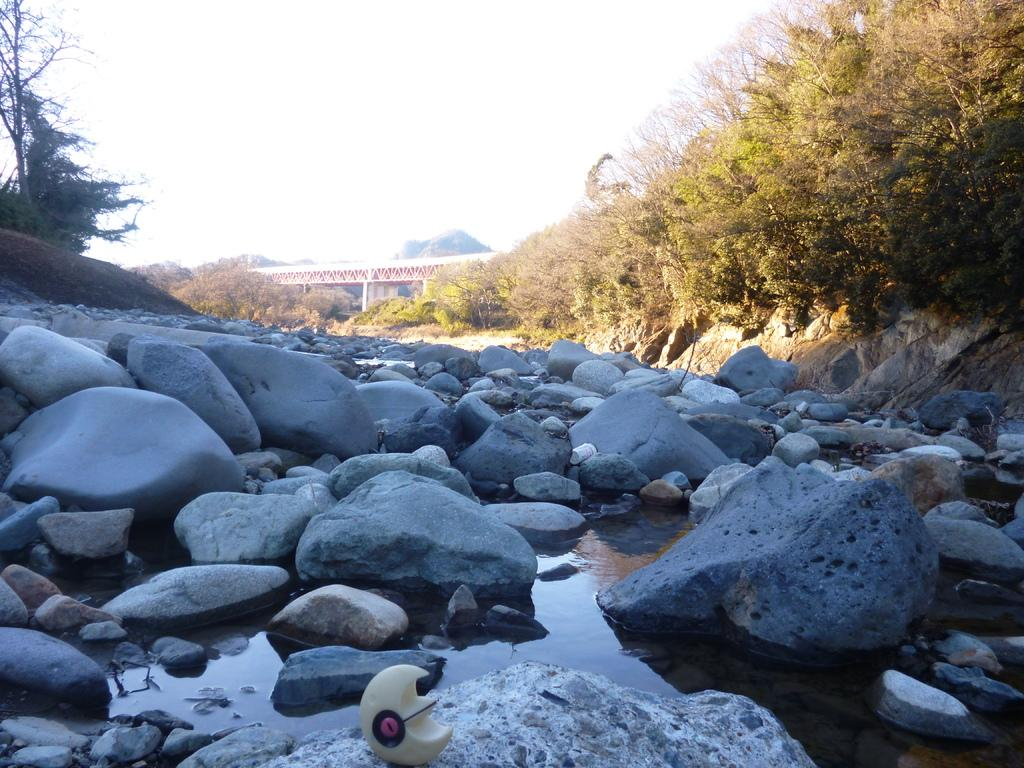What can be seen in the foreground of the image? In the foreground of the image, there is water and rocks. What is located at the bottom of the image? There is an object at the bottom of the image. What type of vegetation is present in the image? There are trees in the image. What man-made structure can be seen in the image? There is a bridge in the image. What natural feature is visible in the background of the image? There are mountains in the image. What part of the natural environment is visible in the image? The sky is visible in the image. What type of crack is visible in the image? There is no crack present in the image. How does the digestion of the trees in the image affect the water in the foreground? The image does not show any trees undergoing digestion, and therefore it cannot be determined how it would affect the water in the foreground. What pets can be seen playing near the rocks in the image? There are no pets present in the image. 